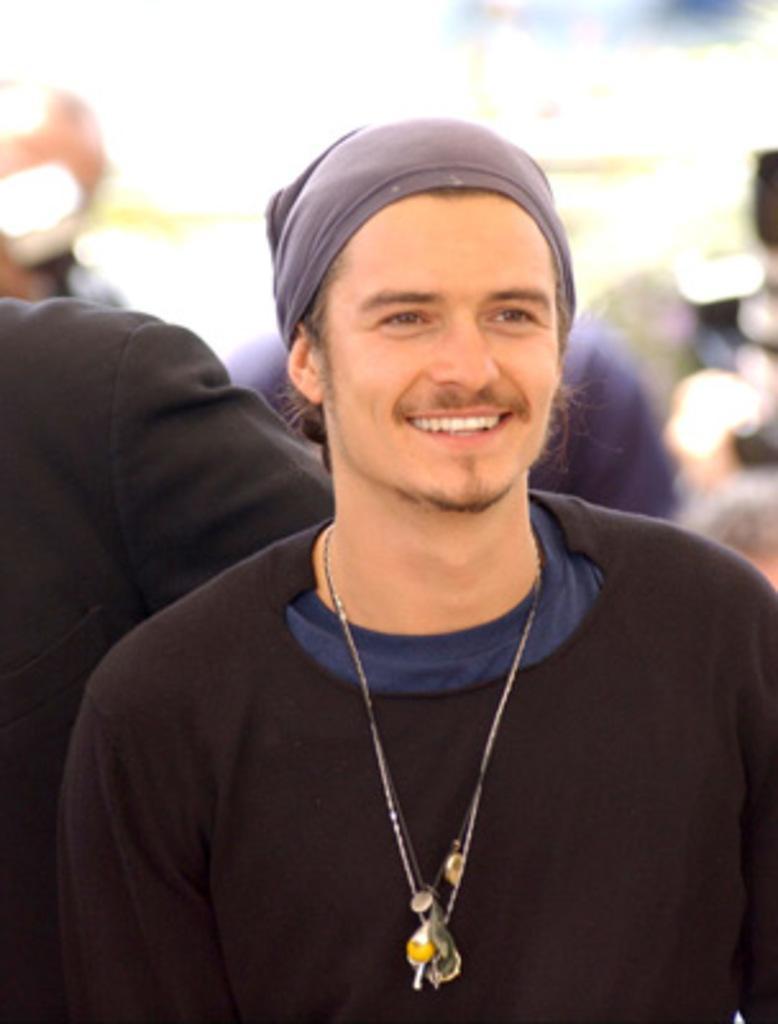Please provide a concise description of this image. The man in front of the picture wearing a black T-shirt is smiling. Behind him, we see a person who is wearing black blazer. In the background, it is blurred. 